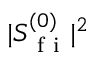<formula> <loc_0><loc_0><loc_500><loc_500>| S _ { f i } ^ { ( 0 ) } | ^ { 2 }</formula> 